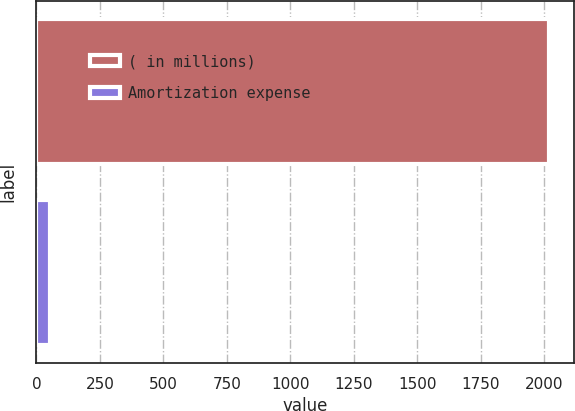Convert chart. <chart><loc_0><loc_0><loc_500><loc_500><bar_chart><fcel>( in millions)<fcel>Amortization expense<nl><fcel>2019<fcel>54<nl></chart> 